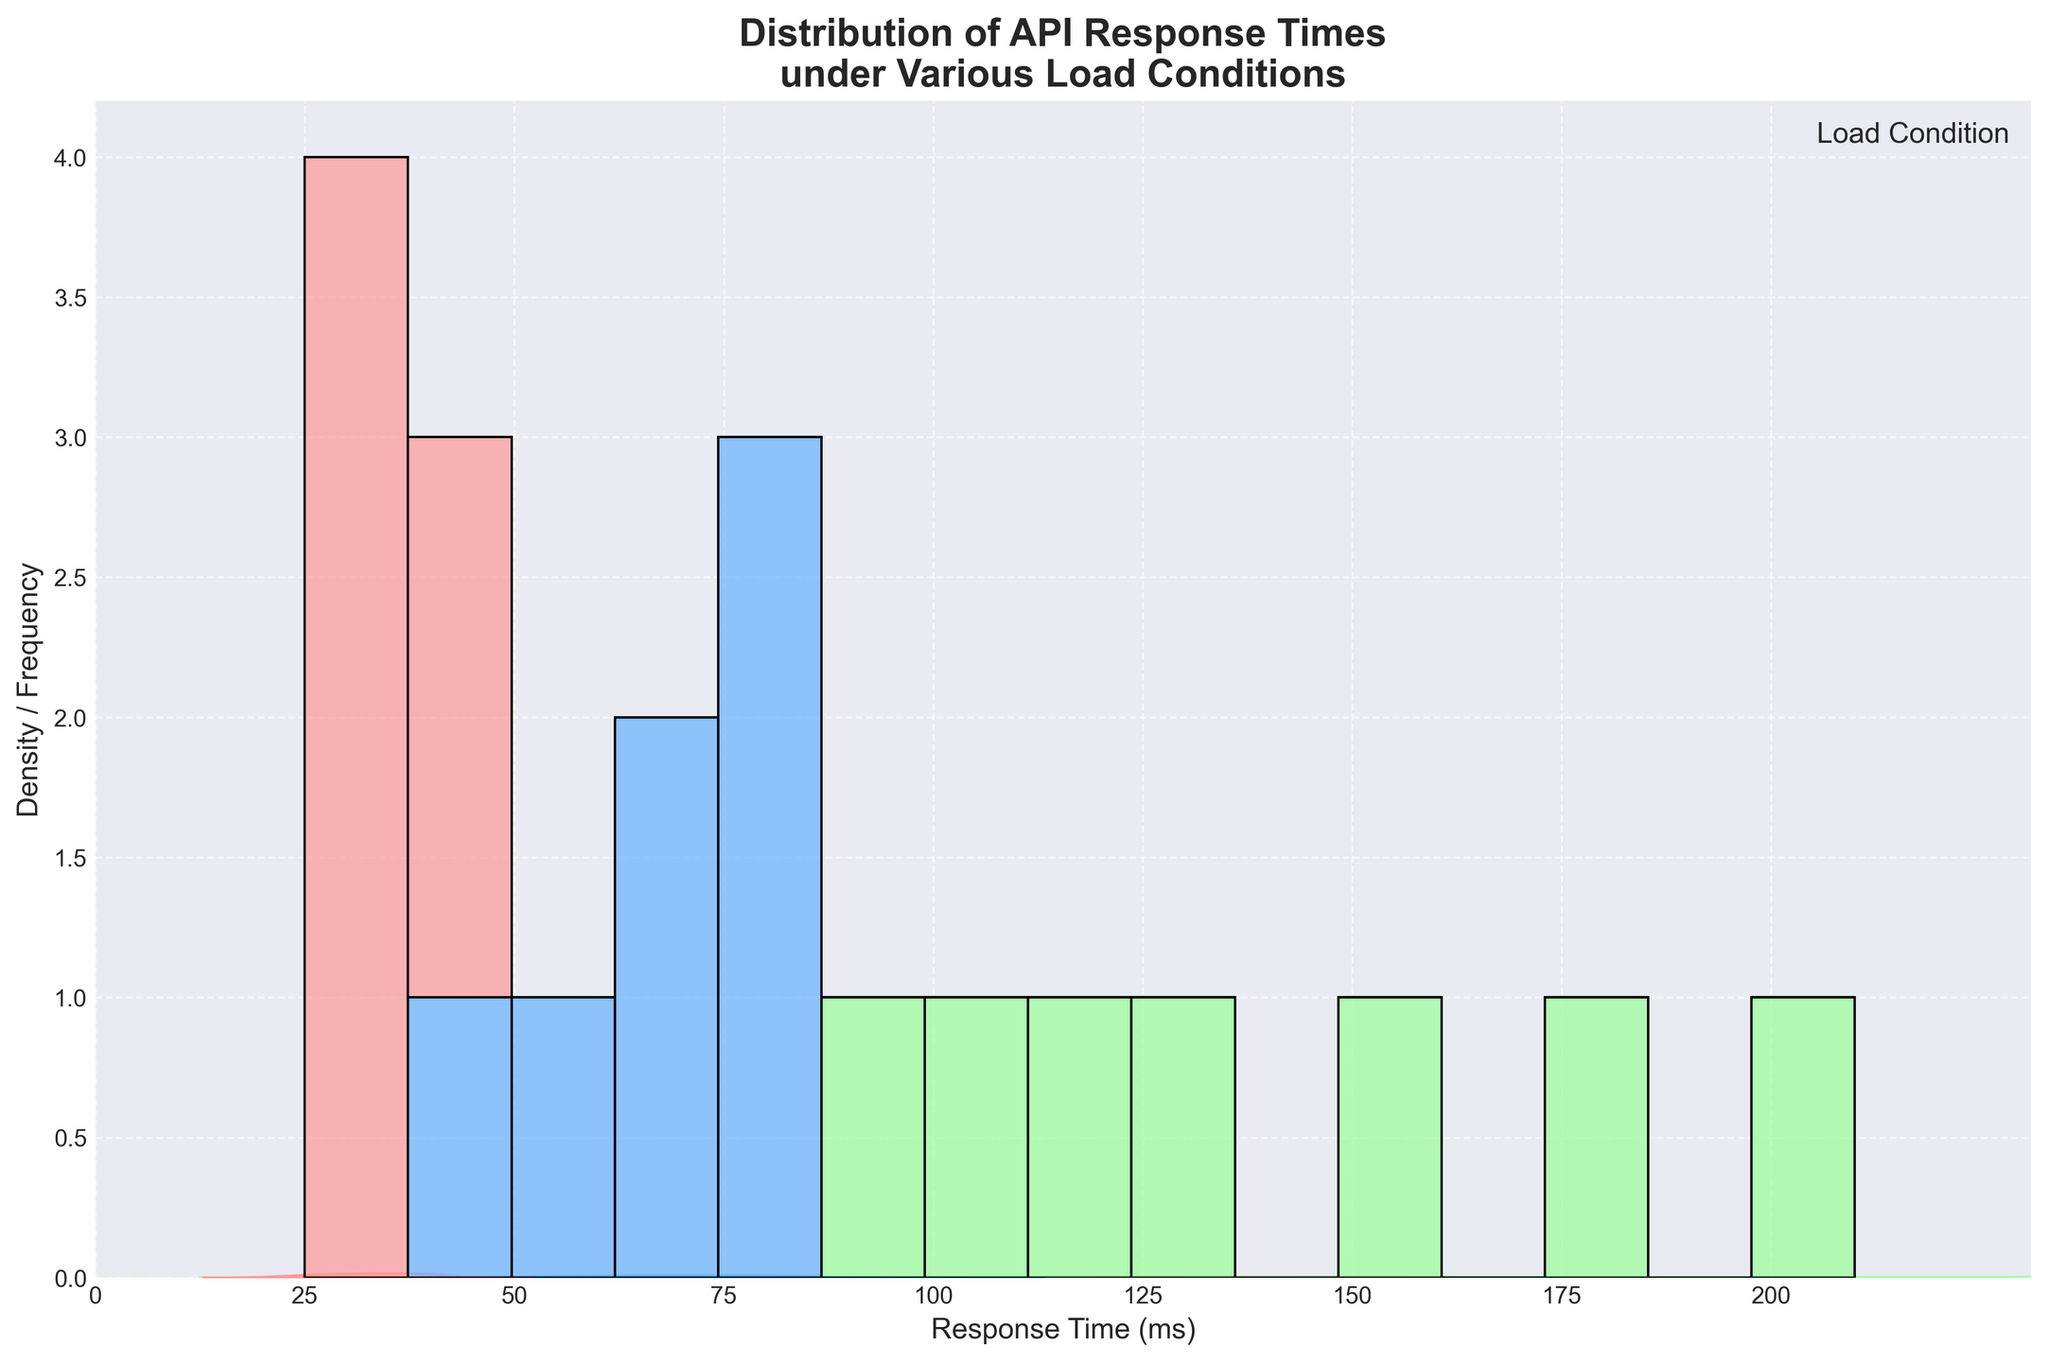What is the title of the plot? The title is usually displayed at the top of the plot, which describes the content. In this figure, the title reads "Distribution of API Response Times under Various Load Conditions."
Answer: Distribution of API Response Times under Various Load Conditions What is on the x-axis of the plot? The x-axis label, found along the bottom horizontal axis, indicates that it represents "Response Time (ms)."
Answer: Response Time (ms) What does the y-axis represent? The y-axis label, located along the left vertical axis, represents "Density / Frequency," indicating that this axis shows both density and frequency of the response times.
Answer: Density / Frequency How many load conditions are shown in the plot? By examining the legend at the upper right, we can count the different load conditions listed. The plot contains three load conditions: Light, Medium, and Heavy.
Answer: Three load conditions Which load condition exhibits the highest response times? Looking at the figure, we see that the "Heavy" load condition has response times extending to the highest values along the x-axis, up to around 210 ms.
Answer: Heavy What is the lowest response time recorded in the plot? By looking at the leftmost values on the x-axis, we can see that the lowest response time recorded is around 25 ms, under the Light load condition.
Answer: 25 ms Which load condition shows the highest density peak in the KDE plot? By observing the density curves in the KDE plot, the "Light" load condition shows the sharpest peak, indicating the highest density of response times around the lower end of the x-axis.
Answer: Light What range of response times do most 'Medium' load condition data points fall into? Examining the histogram bars and KDE plot for the 'Medium' load condition, the majority of data points fall into the range from approximately 45 ms to 85 ms on the x-axis.
Answer: 45 ms to 85 ms Which load condition shows a wider spread of response times? By looking at the distribution spread on the x-axis, the "Heavy" load condition shows the widest range, from approximately 95 ms to 210 ms, indicating a broader spread of response times.
Answer: Heavy Between which response times is the highest frequency observed for 'Heavy' load condition? By examining the histogram's tallest bars for the 'Heavy' load condition, the highest frequency is observed between approximately 110 ms and 150 ms.
Answer: 110 ms to 150 ms 